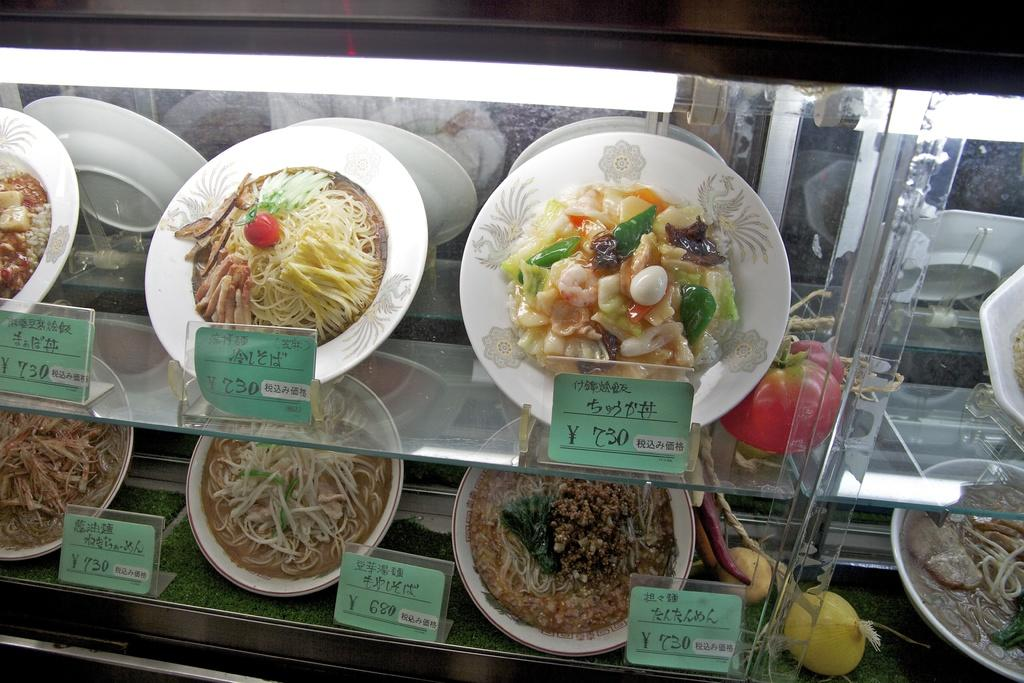What can be seen on the plates in the image? There are food items on the plates in the image. What else is present in the image besides the plates with food? There are price boards in racks in the image. How does the truck affect the food on the plates in the image? There is no truck present in the image, so it cannot affect the food on the plates. 